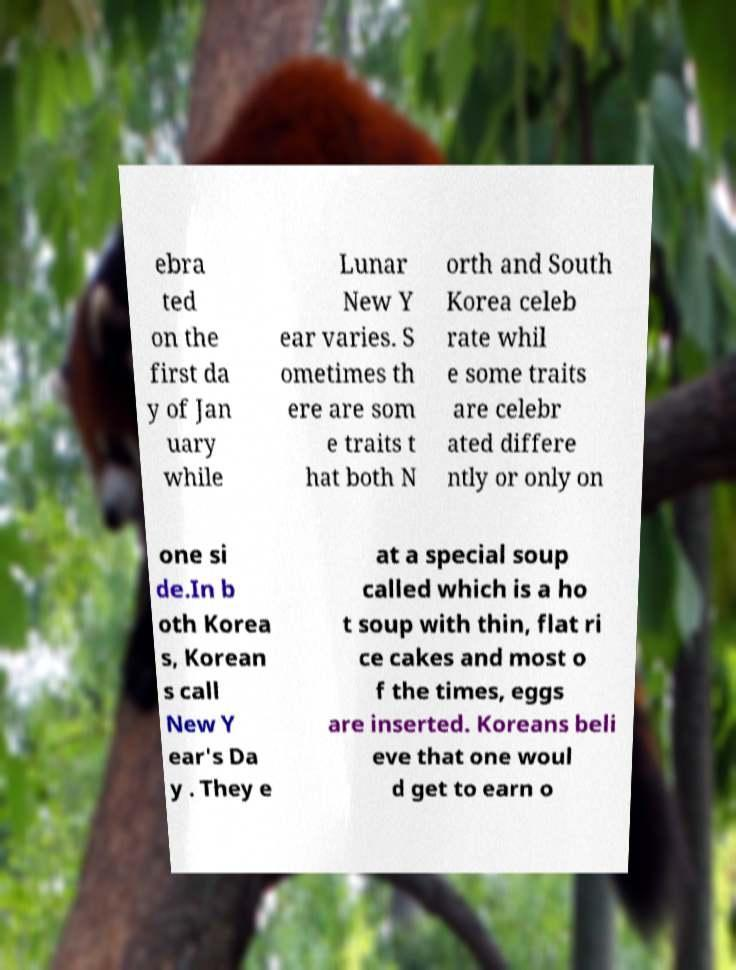Could you assist in decoding the text presented in this image and type it out clearly? ebra ted on the first da y of Jan uary while Lunar New Y ear varies. S ometimes th ere are som e traits t hat both N orth and South Korea celeb rate whil e some traits are celebr ated differe ntly or only on one si de.In b oth Korea s, Korean s call New Y ear's Da y . They e at a special soup called which is a ho t soup with thin, flat ri ce cakes and most o f the times, eggs are inserted. Koreans beli eve that one woul d get to earn o 